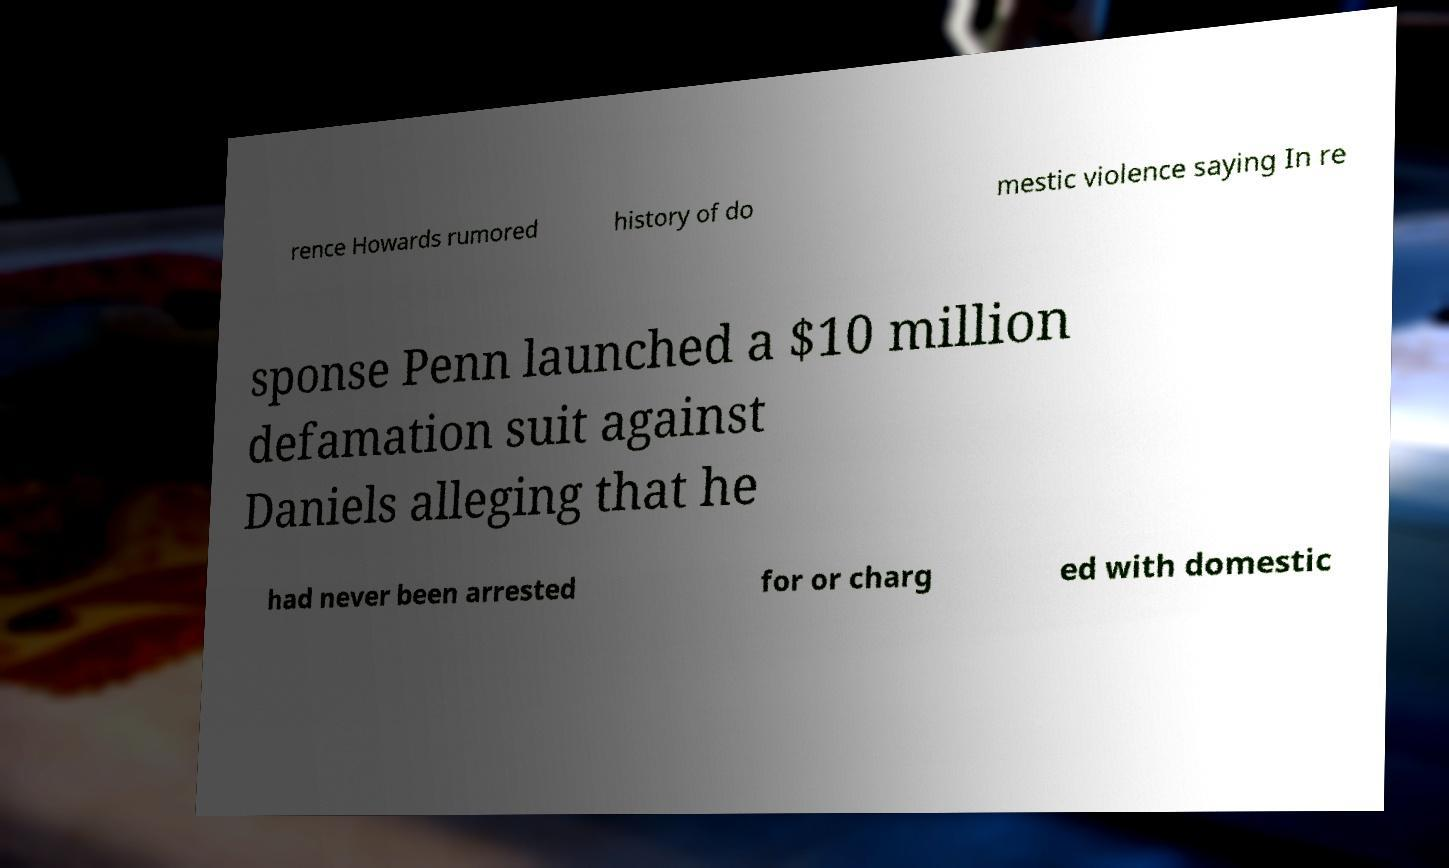Please read and relay the text visible in this image. What does it say? rence Howards rumored history of do mestic violence saying In re sponse Penn launched a $10 million defamation suit against Daniels alleging that he had never been arrested for or charg ed with domestic 